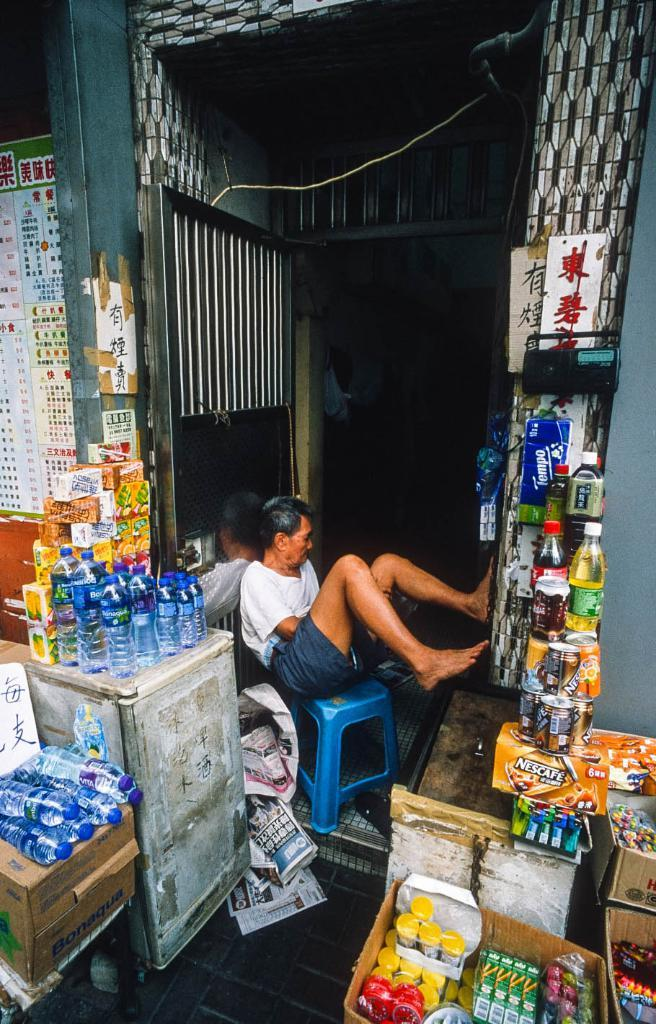<image>
Give a short and clear explanation of the subsequent image. A man is sitting surrounded by products, including something from Nescafe. 